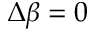Convert formula to latex. <formula><loc_0><loc_0><loc_500><loc_500>\Delta \beta = 0</formula> 